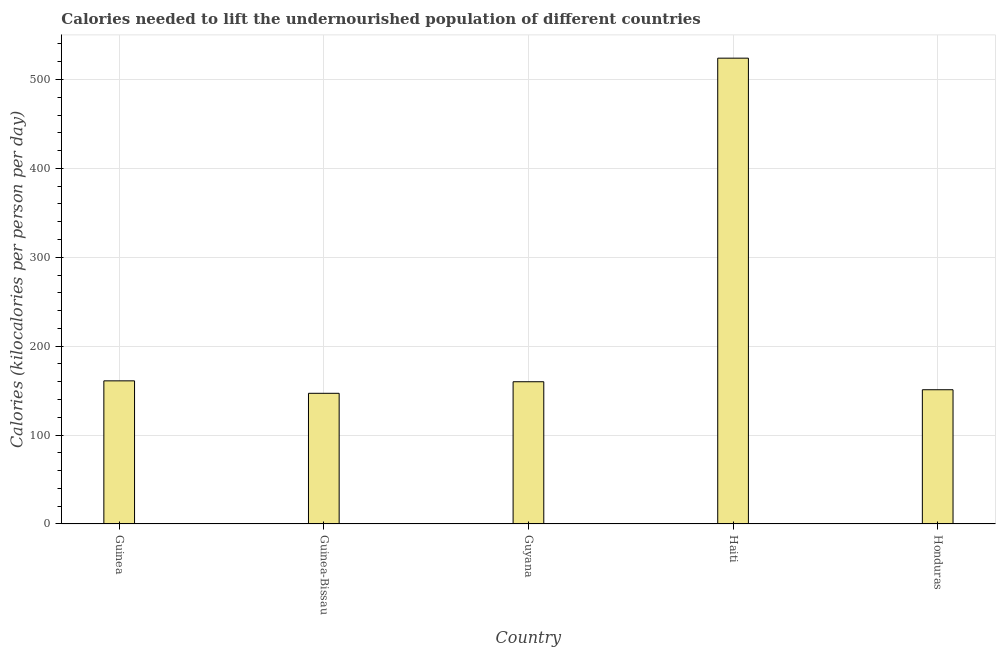Does the graph contain grids?
Your answer should be compact. Yes. What is the title of the graph?
Give a very brief answer. Calories needed to lift the undernourished population of different countries. What is the label or title of the Y-axis?
Give a very brief answer. Calories (kilocalories per person per day). What is the depth of food deficit in Haiti?
Offer a very short reply. 524. Across all countries, what is the maximum depth of food deficit?
Offer a very short reply. 524. Across all countries, what is the minimum depth of food deficit?
Offer a very short reply. 147. In which country was the depth of food deficit maximum?
Provide a succinct answer. Haiti. In which country was the depth of food deficit minimum?
Provide a short and direct response. Guinea-Bissau. What is the sum of the depth of food deficit?
Your response must be concise. 1143. What is the average depth of food deficit per country?
Your answer should be compact. 228.6. What is the median depth of food deficit?
Keep it short and to the point. 160. In how many countries, is the depth of food deficit greater than 280 kilocalories?
Your answer should be compact. 1. What is the ratio of the depth of food deficit in Guinea-Bissau to that in Haiti?
Provide a succinct answer. 0.28. Is the depth of food deficit in Guinea less than that in Guyana?
Your answer should be compact. No. What is the difference between the highest and the second highest depth of food deficit?
Provide a succinct answer. 363. What is the difference between the highest and the lowest depth of food deficit?
Your response must be concise. 377. In how many countries, is the depth of food deficit greater than the average depth of food deficit taken over all countries?
Your response must be concise. 1. Are all the bars in the graph horizontal?
Offer a very short reply. No. How many countries are there in the graph?
Offer a very short reply. 5. What is the Calories (kilocalories per person per day) in Guinea?
Your answer should be compact. 161. What is the Calories (kilocalories per person per day) of Guinea-Bissau?
Make the answer very short. 147. What is the Calories (kilocalories per person per day) in Guyana?
Make the answer very short. 160. What is the Calories (kilocalories per person per day) in Haiti?
Provide a short and direct response. 524. What is the Calories (kilocalories per person per day) in Honduras?
Offer a terse response. 151. What is the difference between the Calories (kilocalories per person per day) in Guinea and Guinea-Bissau?
Provide a short and direct response. 14. What is the difference between the Calories (kilocalories per person per day) in Guinea and Guyana?
Your answer should be very brief. 1. What is the difference between the Calories (kilocalories per person per day) in Guinea and Haiti?
Offer a terse response. -363. What is the difference between the Calories (kilocalories per person per day) in Guinea-Bissau and Haiti?
Your response must be concise. -377. What is the difference between the Calories (kilocalories per person per day) in Guyana and Haiti?
Provide a succinct answer. -364. What is the difference between the Calories (kilocalories per person per day) in Haiti and Honduras?
Your response must be concise. 373. What is the ratio of the Calories (kilocalories per person per day) in Guinea to that in Guinea-Bissau?
Offer a terse response. 1.09. What is the ratio of the Calories (kilocalories per person per day) in Guinea to that in Haiti?
Give a very brief answer. 0.31. What is the ratio of the Calories (kilocalories per person per day) in Guinea to that in Honduras?
Provide a short and direct response. 1.07. What is the ratio of the Calories (kilocalories per person per day) in Guinea-Bissau to that in Guyana?
Offer a terse response. 0.92. What is the ratio of the Calories (kilocalories per person per day) in Guinea-Bissau to that in Haiti?
Make the answer very short. 0.28. What is the ratio of the Calories (kilocalories per person per day) in Guyana to that in Haiti?
Give a very brief answer. 0.3. What is the ratio of the Calories (kilocalories per person per day) in Guyana to that in Honduras?
Give a very brief answer. 1.06. What is the ratio of the Calories (kilocalories per person per day) in Haiti to that in Honduras?
Provide a short and direct response. 3.47. 